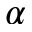<formula> <loc_0><loc_0><loc_500><loc_500>\alpha</formula> 